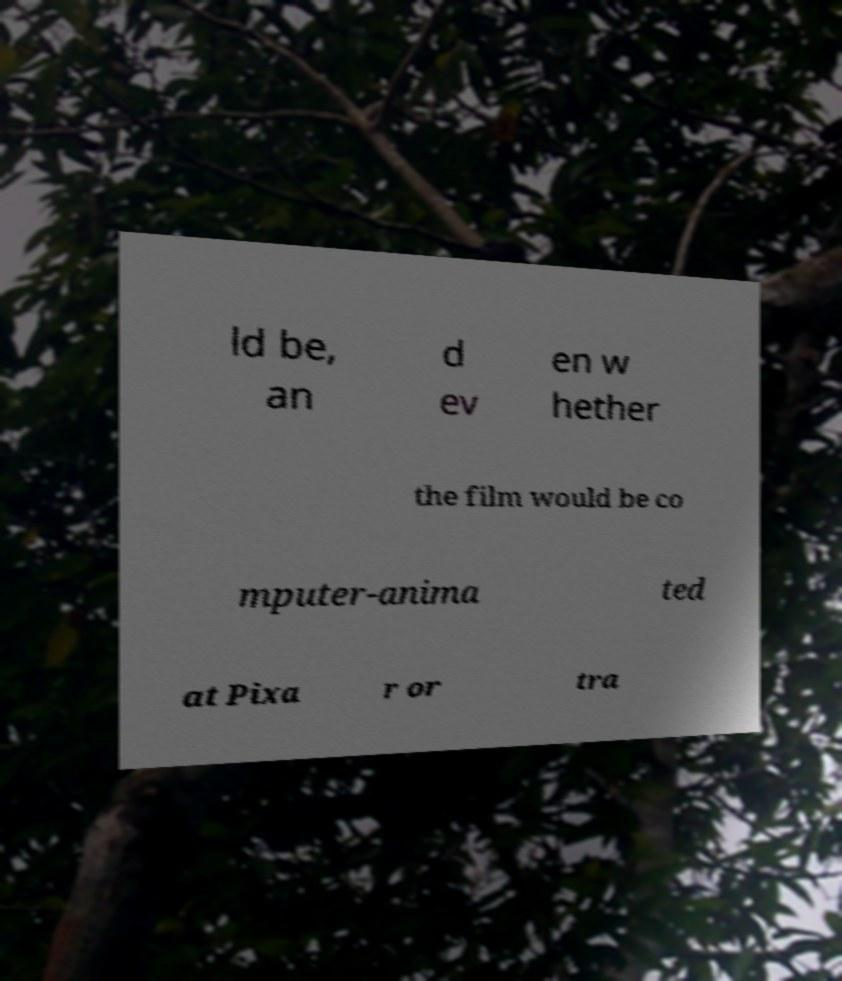Could you assist in decoding the text presented in this image and type it out clearly? ld be, an d ev en w hether the film would be co mputer-anima ted at Pixa r or tra 